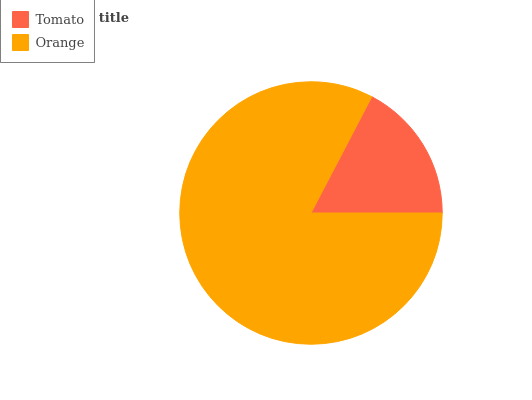Is Tomato the minimum?
Answer yes or no. Yes. Is Orange the maximum?
Answer yes or no. Yes. Is Orange the minimum?
Answer yes or no. No. Is Orange greater than Tomato?
Answer yes or no. Yes. Is Tomato less than Orange?
Answer yes or no. Yes. Is Tomato greater than Orange?
Answer yes or no. No. Is Orange less than Tomato?
Answer yes or no. No. Is Orange the high median?
Answer yes or no. Yes. Is Tomato the low median?
Answer yes or no. Yes. Is Tomato the high median?
Answer yes or no. No. Is Orange the low median?
Answer yes or no. No. 